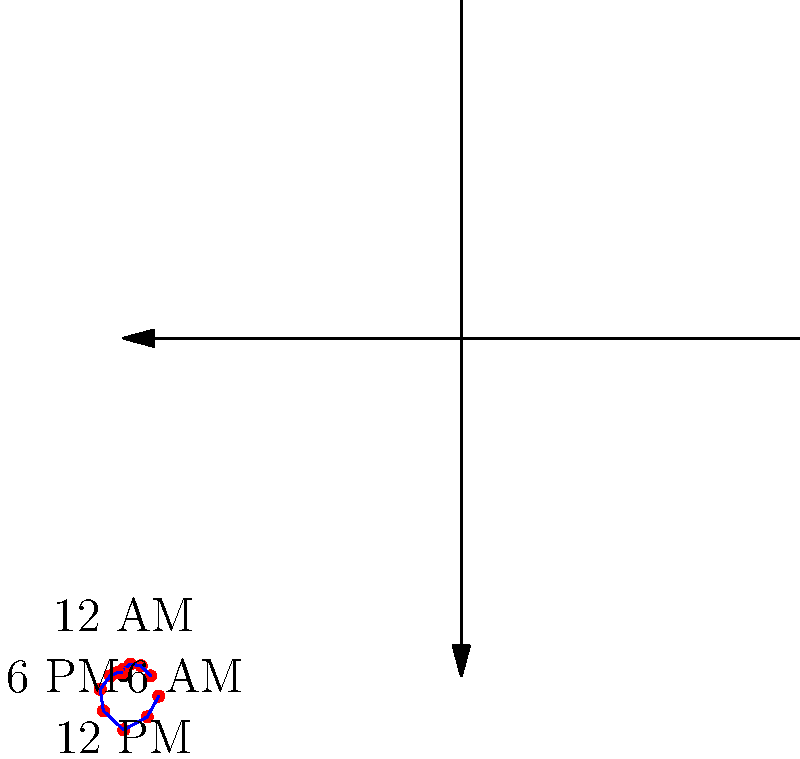Based on the polar clock diagram showing fatigue levels throughout a 24-hour period, at which time does the fatigue level reach its peak for night shift workers? To determine the peak fatigue level for night shift workers, let's analyze the polar clock diagram step-by-step:

1. The diagram represents a 24-hour clock, with 12 AM at the top and 12 PM at the bottom.
2. The distance from the center represents the fatigue level, with greater distance indicating higher fatigue.
3. The blue line connects the data points, showing the progression of fatigue over time.
4. Examining the diagram clockwise:
   - Fatigue is low from around 4 AM to 6 AM.
   - It starts to increase gradually from 6 AM onwards.
   - There's a sharp increase in fatigue levels from about 6 PM to 9 PM.
   - The highest point on the graph, representing peak fatigue, occurs at the 9 o'clock position.
5. The 9 o'clock position on a 24-hour clock corresponds to 9 PM.

Therefore, based on this diagram, the fatigue level for night shift workers reaches its peak at 9 PM.

This pattern is consistent with the circadian rhythm of night shift workers, where fatigue typically peaks in the evening hours as they struggle against their natural sleep-wake cycle.
Answer: 9 PM 